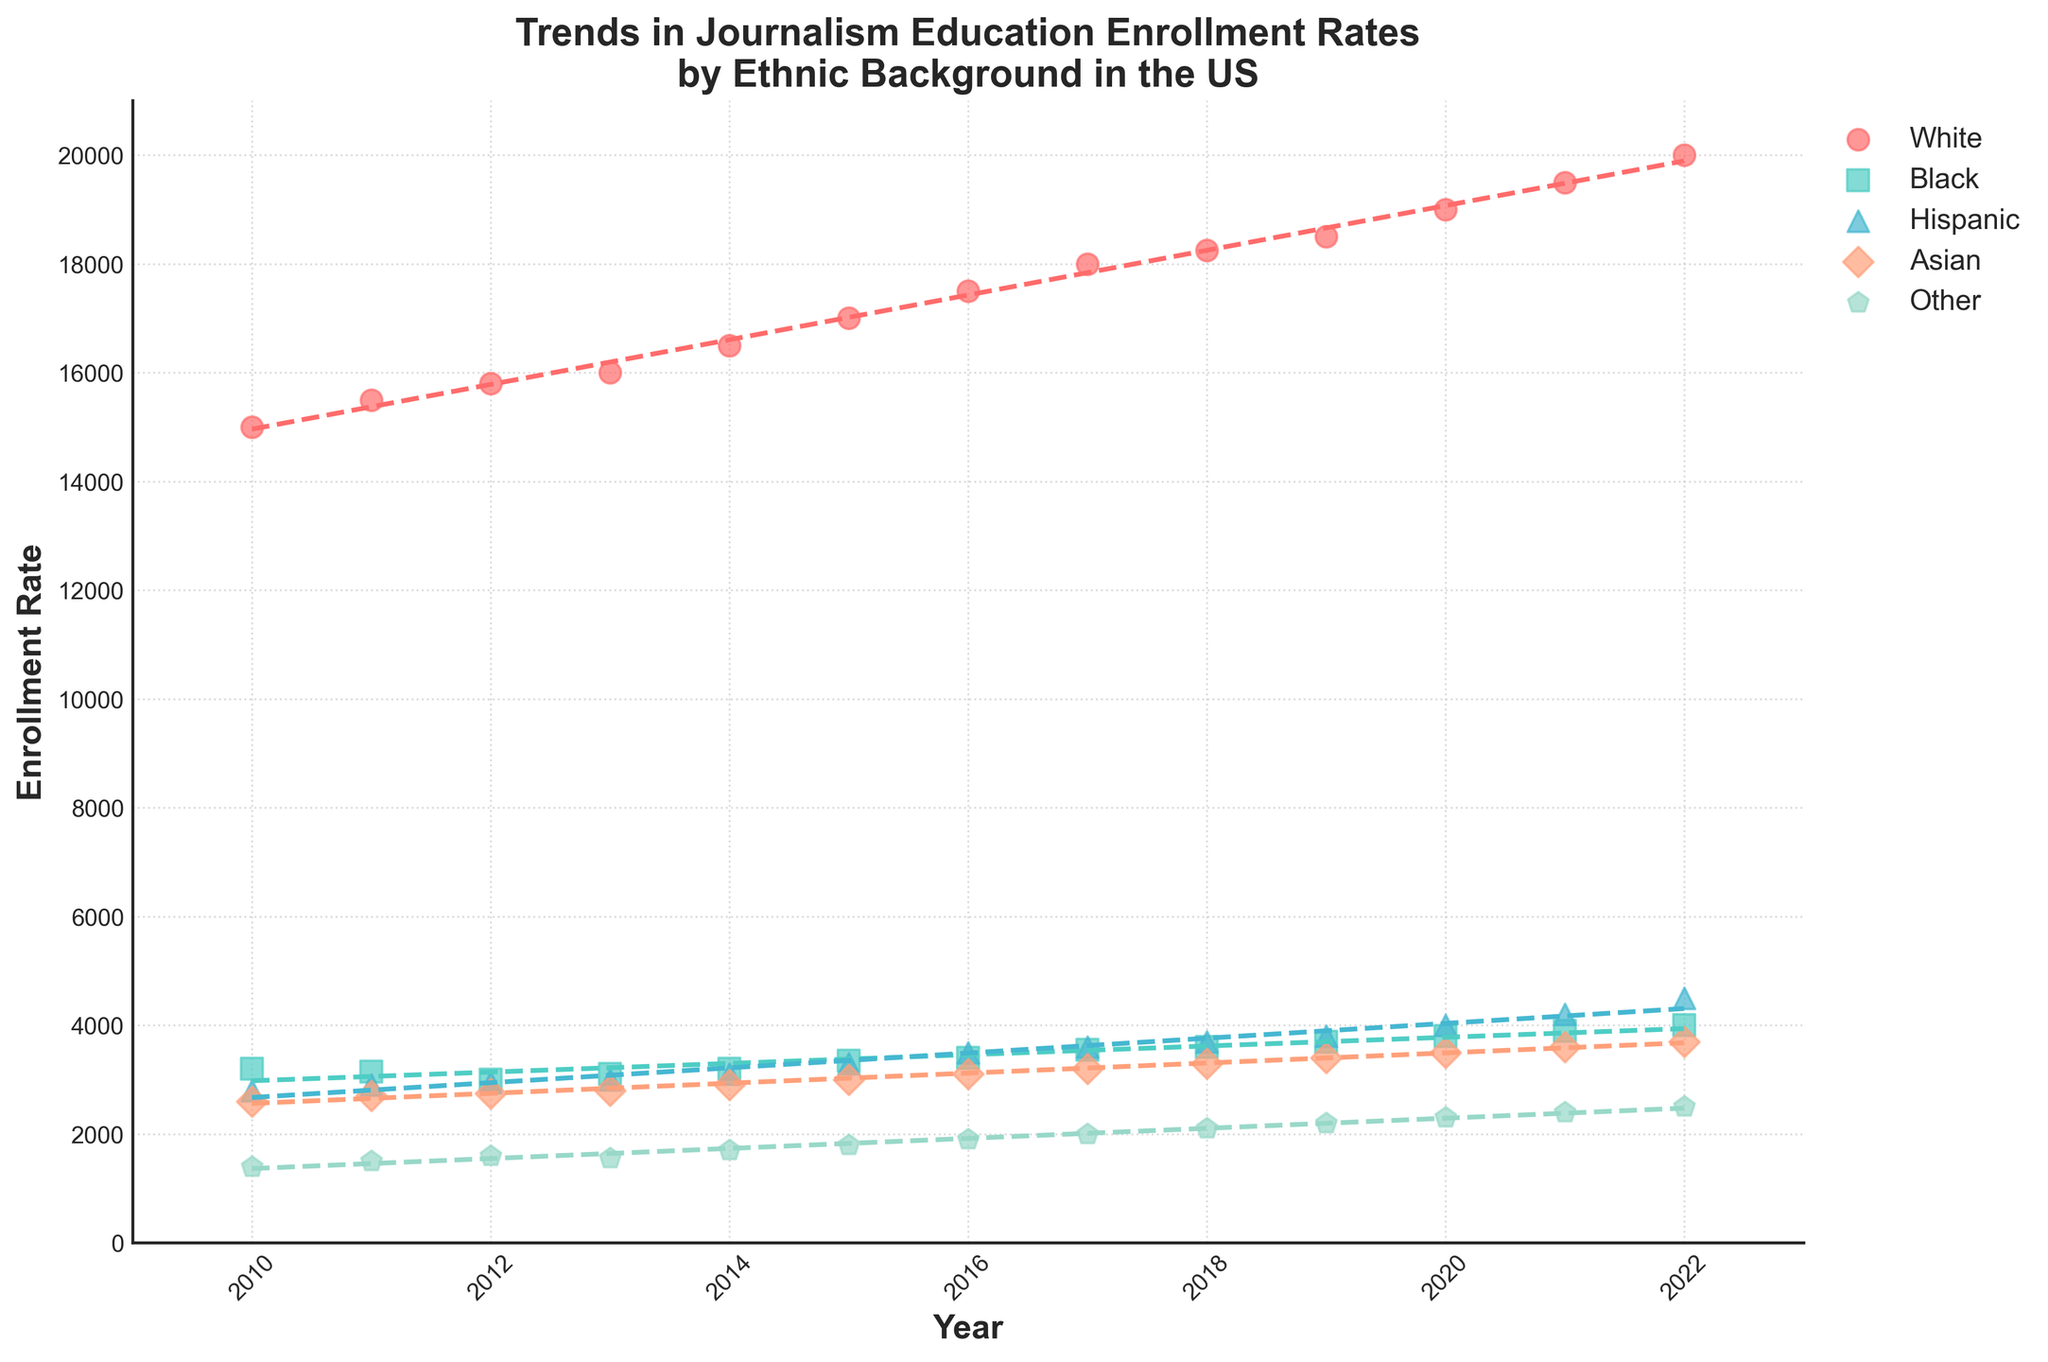What is the title of the figure? The title is located at the top of the figure and summarizes the data visually represented. For this plot, the title mentions trends in enrollment rates by ethnic background.
Answer: Trends in Journalism Education Enrollment Rates by Ethnic Background in the US How many ethnic backgrounds are displayed in the plot? Each ethnic background has a corresponding color and marker type in the scatter plot. By observing the legend on the right side of the figure, we can count the different ethnic backgrounds.
Answer: 5 Which ethnic group had the highest enrollment rate in 2020? To find this, locate the year 2020 on the x-axis and identify which scatter point along that vertical line is the highest on the y-axis.
Answer: White What average enrollment rate over the years is shown for the Hispanic ethnic background? We need to find the sum of the Hispanic enrollment rates from each year and then divide by the number of years (13 years).
Answer: (2800+2900+2950+3000+3100+3300+3500+3600+3700+3800+4000+4200+4500) / 13 = 3523.1 Between 2010 and 2022, which ethnic group showed the greatest increase in enrollment rate? Calculate the difference between the 2022 and 2010 values for each ethnic group and find the largest difference.
Answer: Hispanic (4500 - 2800 = 1700) Is there a trend line for each ethnic background, and if so, what type of trend line is it? Each scatter group is connected by trend lines, which provides insight into general trends. By examining the visual styles, they appear as dashed lines, indicating linear regressions.
Answer: Yes, linear In what year did Black journalism education enrollment start to show a steady increase after a period of decline? Identify the point where the Black enrollment scatter points stop decreasing and show continuous growth afterward. This can be seen from 2014 onwards.
Answer: 2014 Which ethnic group had an enrollment rate closest to 4000 in 2021? Locate the year 2021 on the x-axis and look for the scatter point closest to 4000 on the y-axis.
Answer: Hispanic For which ethnic background did the trend line slope appear steepest? Examine the trend lines of each ethnic group and identify which line has the steepest incline. This indicates the fastest increasing enrollment rate.
Answer: Hispanic How does the enrollment trend for the 'Other' ethnic background compare to the trend for the Asian background? Compare the slopes of the trend lines for both ethnic backgrounds. The steeper the slope, the more rapid the increase in enrollment. The 'Other' ethnic background shows a slower and more gradual increase compared to the Asian background.
Answer: 'Other' has a slower increase compared to Asian 